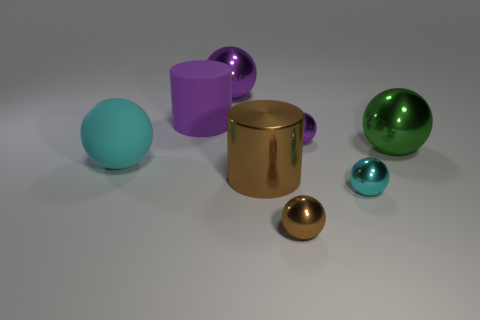What number of spheres are tiny cyan things or large green shiny objects?
Your answer should be compact. 2. There is a small metal thing that is both in front of the green object and behind the brown sphere; what shape is it?
Provide a succinct answer. Sphere. There is a big metallic thing in front of the large object on the left side of the cylinder behind the big green shiny object; what is its color?
Keep it short and to the point. Brown. Are there fewer large cyan rubber objects that are behind the big purple sphere than big brown metal balls?
Your answer should be compact. No. Is the shape of the purple shiny thing that is right of the big brown metal object the same as the purple metallic object that is behind the purple matte cylinder?
Provide a short and direct response. Yes. What number of things are big cylinders to the right of the large rubber cylinder or purple objects?
Offer a very short reply. 4. There is a big sphere that is the same color as the rubber cylinder; what is it made of?
Your answer should be very brief. Metal. There is a cylinder on the right side of the purple metallic object behind the big matte cylinder; are there any purple spheres on the right side of it?
Provide a succinct answer. Yes. Is the number of large purple rubber things to the right of the purple cylinder less than the number of tiny brown shiny balls in front of the cyan shiny sphere?
Offer a terse response. Yes. What color is the big cylinder that is the same material as the large purple sphere?
Offer a terse response. Brown. 